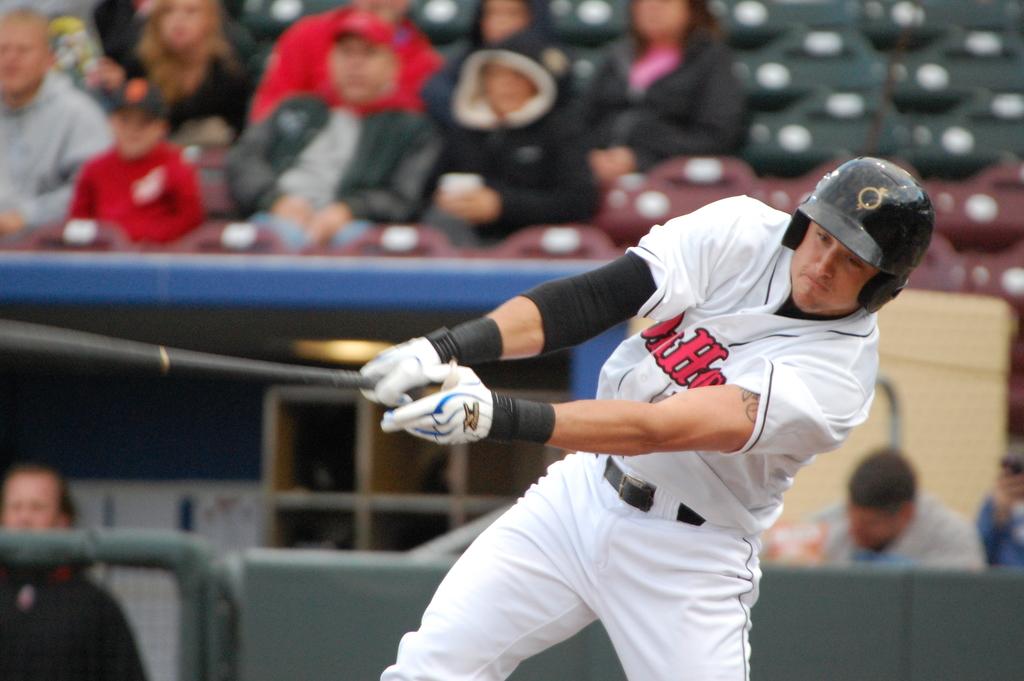What red letter is clearly visible on him?
Provide a succinct answer. H. 